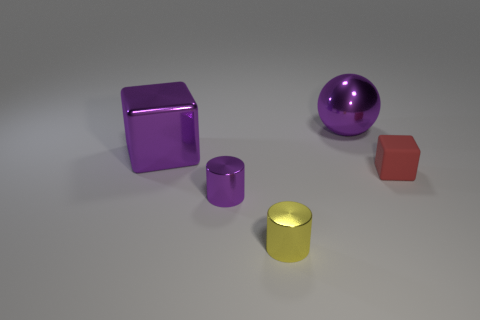Subtract 2 cubes. How many cubes are left? 0 Subtract all purple cylinders. How many cylinders are left? 1 Add 4 big green matte cubes. How many objects exist? 9 Subtract 0 cyan balls. How many objects are left? 5 Subtract all cylinders. How many objects are left? 3 Subtract all blue balls. Subtract all yellow cylinders. How many balls are left? 1 Subtract all big metallic blocks. Subtract all brown matte things. How many objects are left? 4 Add 4 yellow things. How many yellow things are left? 5 Add 1 large cyan metal balls. How many large cyan metal balls exist? 1 